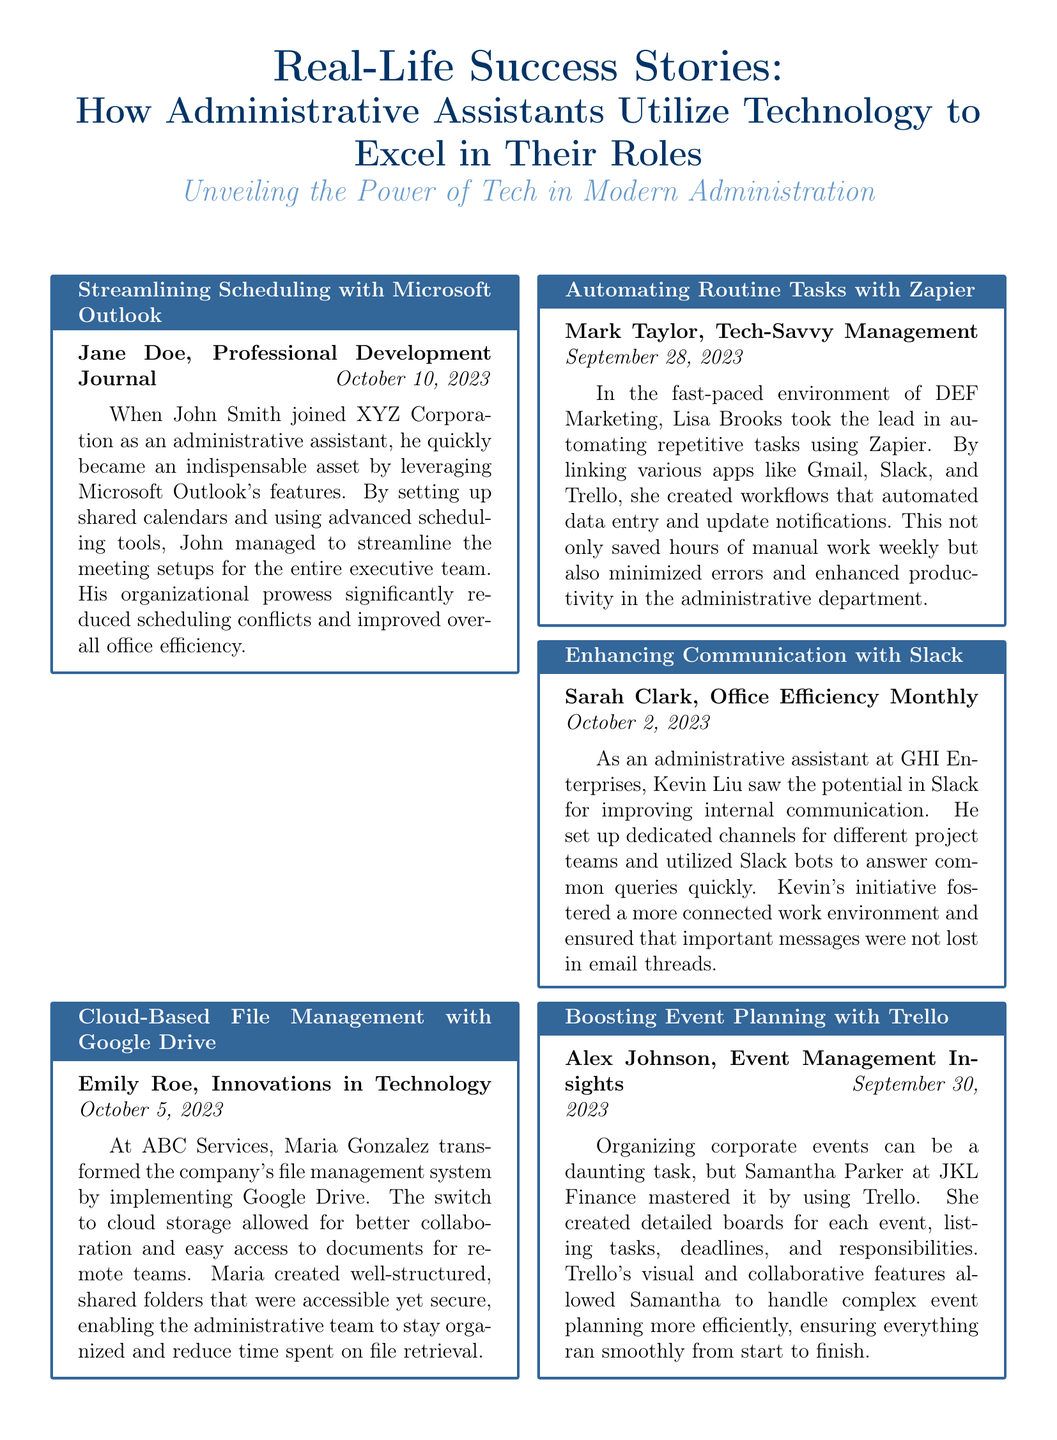What is the title of the article? The title of the article, as presented in the document, is "Real-Life Success Stories: How Administrative Assistants Utilize Technology to Excel in Their Roles."
Answer: Real-Life Success Stories: How Administrative Assistants Utilize Technology to Excel in Their Roles Who is the author of the article on scheduling with Microsoft Outlook? The author of the article on scheduling with Microsoft Outlook is Jane Doe.
Answer: Jane Doe Which technology did Maria Gonzalez use for file management? Maria Gonzalez implemented Google Drive for file management at ABC Services.
Answer: Google Drive What date was the article about automating tasks with Zapier published? The article about automating tasks with Zapier was published on September 28, 2023.
Answer: September 28, 2023 Which administrative assistant improved internal communication at GHI Enterprises? Kevin Liu improved internal communication at GHI Enterprises.
Answer: Kevin Liu How did Samantha Parker organize corporate events? Samantha Parker mastered organizing corporate events by using Trello.
Answer: Trello What was the main benefit of using Slack according to Kevin Liu? Kevin Liu mentioned that Slack fostered a more connected work environment.
Answer: Connected work environment How did John Smith impact office efficiency at XYZ Corporation? John Smith's organizational prowess significantly reduced scheduling conflicts and improved overall office efficiency.
Answer: Reduced scheduling conflicts What type of document is this? This document follows a newspaper layout format, presenting various articles.
Answer: Newspaper layout 